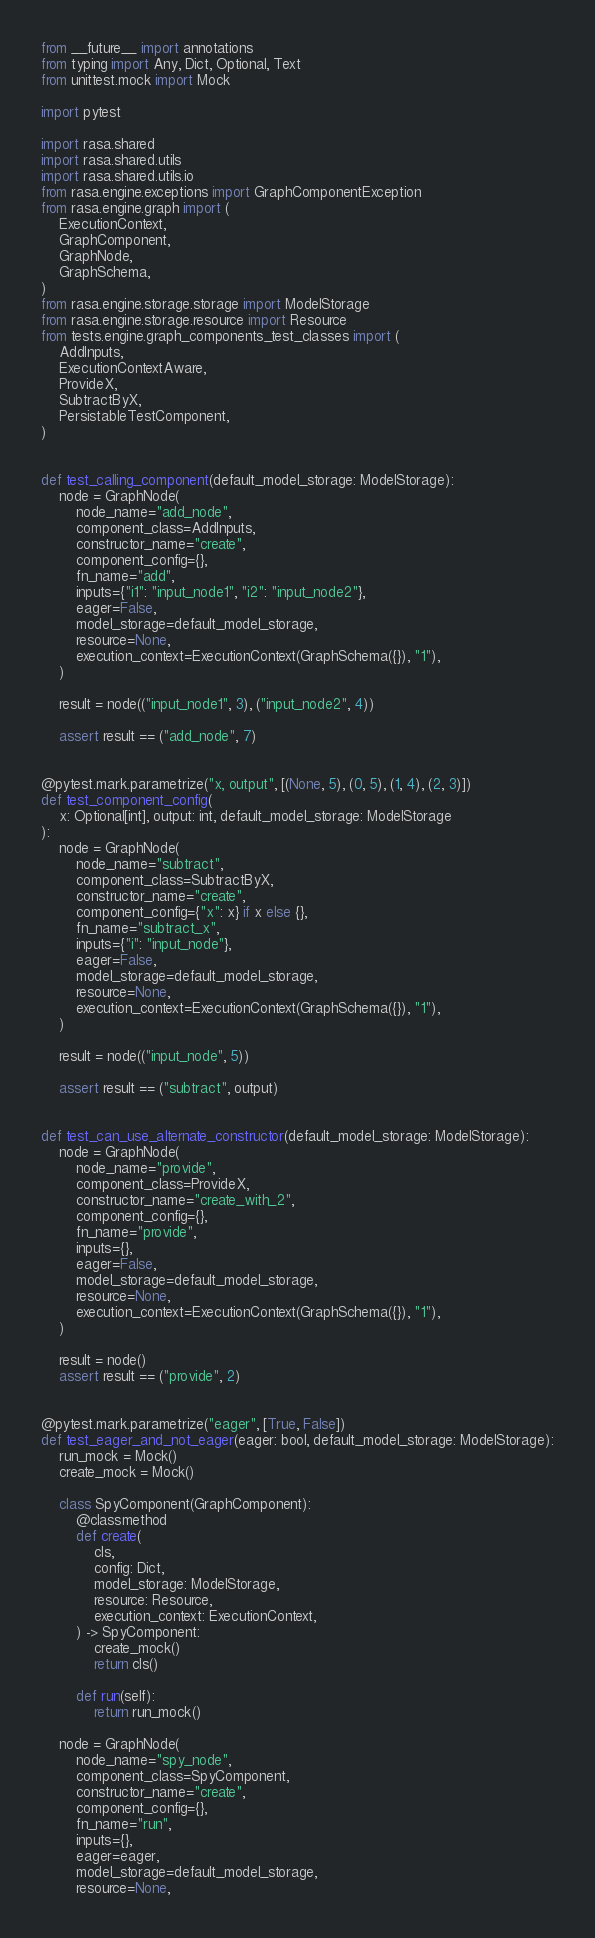<code> <loc_0><loc_0><loc_500><loc_500><_Python_>from __future__ import annotations
from typing import Any, Dict, Optional, Text
from unittest.mock import Mock

import pytest

import rasa.shared
import rasa.shared.utils
import rasa.shared.utils.io
from rasa.engine.exceptions import GraphComponentException
from rasa.engine.graph import (
    ExecutionContext,
    GraphComponent,
    GraphNode,
    GraphSchema,
)
from rasa.engine.storage.storage import ModelStorage
from rasa.engine.storage.resource import Resource
from tests.engine.graph_components_test_classes import (
    AddInputs,
    ExecutionContextAware,
    ProvideX,
    SubtractByX,
    PersistableTestComponent,
)


def test_calling_component(default_model_storage: ModelStorage):
    node = GraphNode(
        node_name="add_node",
        component_class=AddInputs,
        constructor_name="create",
        component_config={},
        fn_name="add",
        inputs={"i1": "input_node1", "i2": "input_node2"},
        eager=False,
        model_storage=default_model_storage,
        resource=None,
        execution_context=ExecutionContext(GraphSchema({}), "1"),
    )

    result = node(("input_node1", 3), ("input_node2", 4))

    assert result == ("add_node", 7)


@pytest.mark.parametrize("x, output", [(None, 5), (0, 5), (1, 4), (2, 3)])
def test_component_config(
    x: Optional[int], output: int, default_model_storage: ModelStorage
):
    node = GraphNode(
        node_name="subtract",
        component_class=SubtractByX,
        constructor_name="create",
        component_config={"x": x} if x else {},
        fn_name="subtract_x",
        inputs={"i": "input_node"},
        eager=False,
        model_storage=default_model_storage,
        resource=None,
        execution_context=ExecutionContext(GraphSchema({}), "1"),
    )

    result = node(("input_node", 5))

    assert result == ("subtract", output)


def test_can_use_alternate_constructor(default_model_storage: ModelStorage):
    node = GraphNode(
        node_name="provide",
        component_class=ProvideX,
        constructor_name="create_with_2",
        component_config={},
        fn_name="provide",
        inputs={},
        eager=False,
        model_storage=default_model_storage,
        resource=None,
        execution_context=ExecutionContext(GraphSchema({}), "1"),
    )

    result = node()
    assert result == ("provide", 2)


@pytest.mark.parametrize("eager", [True, False])
def test_eager_and_not_eager(eager: bool, default_model_storage: ModelStorage):
    run_mock = Mock()
    create_mock = Mock()

    class SpyComponent(GraphComponent):
        @classmethod
        def create(
            cls,
            config: Dict,
            model_storage: ModelStorage,
            resource: Resource,
            execution_context: ExecutionContext,
        ) -> SpyComponent:
            create_mock()
            return cls()

        def run(self):
            return run_mock()

    node = GraphNode(
        node_name="spy_node",
        component_class=SpyComponent,
        constructor_name="create",
        component_config={},
        fn_name="run",
        inputs={},
        eager=eager,
        model_storage=default_model_storage,
        resource=None,</code> 